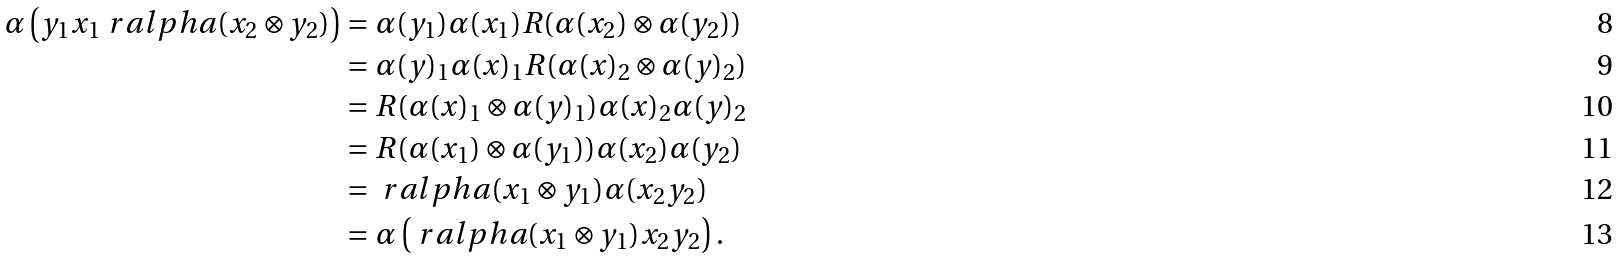Convert formula to latex. <formula><loc_0><loc_0><loc_500><loc_500>\alpha \left ( y _ { 1 } x _ { 1 } \ r a l p h a ( x _ { 2 } \otimes y _ { 2 } ) \right ) & = \alpha ( y _ { 1 } ) \alpha ( x _ { 1 } ) R ( \alpha ( x _ { 2 } ) \otimes \alpha ( y _ { 2 } ) ) \\ & = \alpha ( y ) _ { 1 } \alpha ( x ) _ { 1 } R ( \alpha ( x ) _ { 2 } \otimes \alpha ( y ) _ { 2 } ) \\ & = R ( \alpha ( x ) _ { 1 } \otimes \alpha ( y ) _ { 1 } ) \alpha ( x ) _ { 2 } \alpha ( y ) _ { 2 } \\ & = R ( \alpha ( x _ { 1 } ) \otimes \alpha ( y _ { 1 } ) ) \alpha ( x _ { 2 } ) \alpha ( y _ { 2 } ) \\ & = \ r a l p h a ( x _ { 1 } \otimes y _ { 1 } ) \alpha ( x _ { 2 } y _ { 2 } ) \\ & = \alpha \left ( \ r a l p h a ( x _ { 1 } \otimes y _ { 1 } ) x _ { 2 } y _ { 2 } \right ) .</formula> 